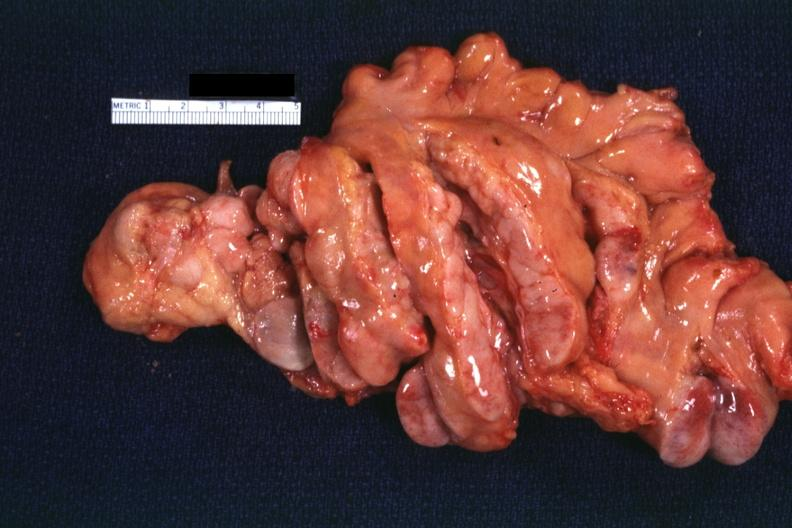what is present?
Answer the question using a single word or phrase. Lymph node 